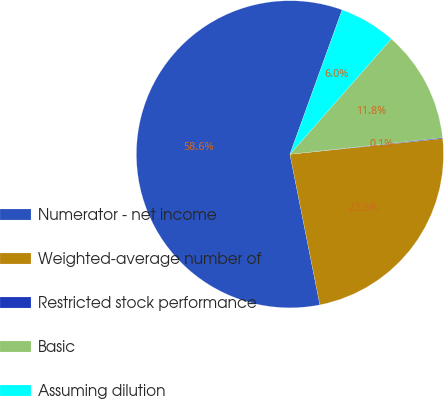<chart> <loc_0><loc_0><loc_500><loc_500><pie_chart><fcel>Numerator - net income<fcel>Weighted-average number of<fcel>Restricted stock performance<fcel>Basic<fcel>Assuming dilution ⎯⎯⎯⎯⎯⎯⎯⎯⎯⎯<nl><fcel>58.64%<fcel>23.51%<fcel>0.09%<fcel>11.8%<fcel>5.95%<nl></chart> 